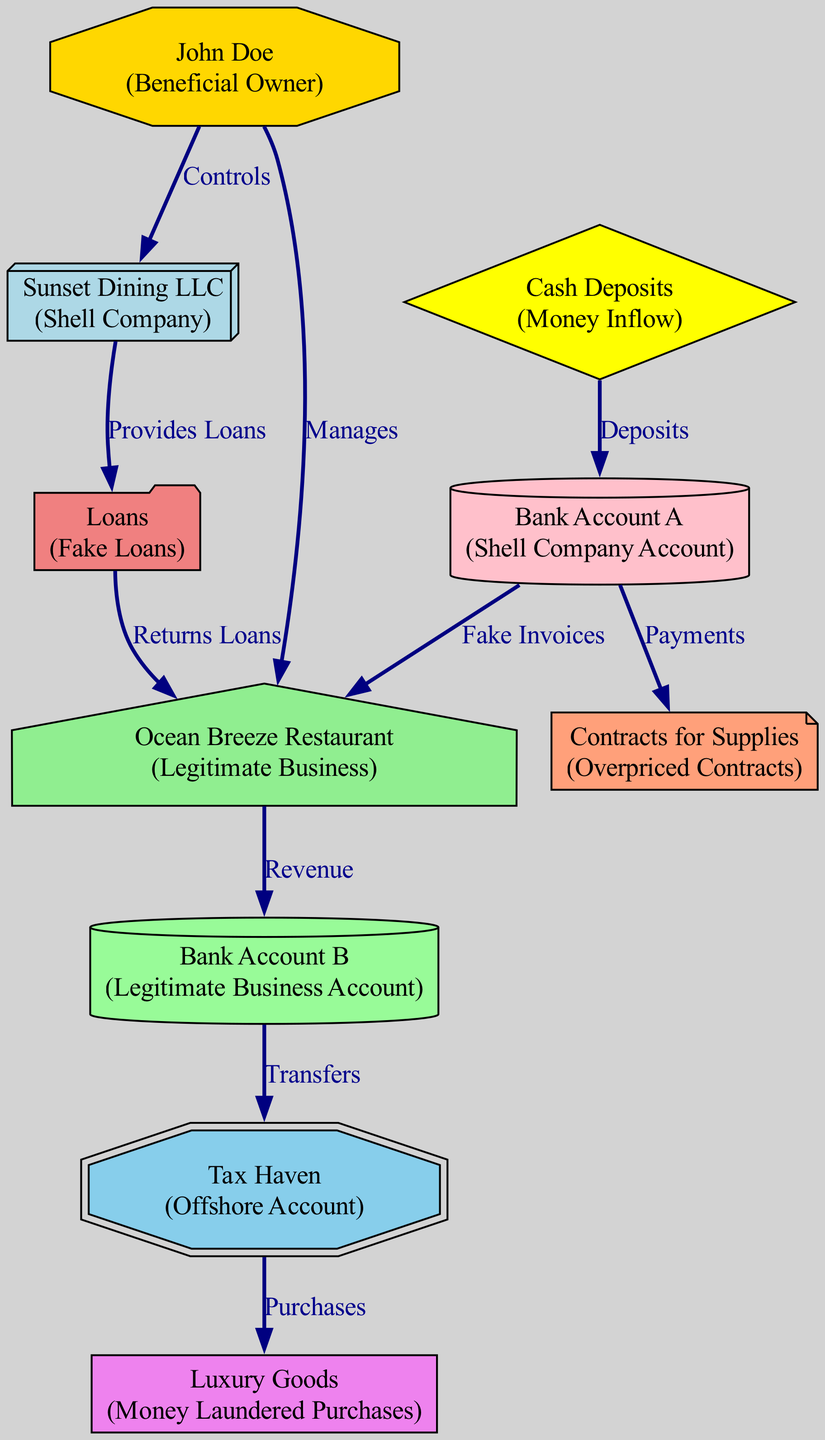What is the total number of nodes in the diagram? The diagram lists 10 distinct entities, including both companies and accounts. Each unique label represents a node in the structure.
Answer: 10 Who is the beneficial owner of Sunset Dining LLC? John Doe is identified in the diagram as the individual who controls the shell company, Sunset Dining LLC, indicating his role as beneficial owner.
Answer: John Doe What type of business is Ocean Breeze Restaurant? The diagram classifies Ocean Breeze Restaurant as a legitimate business, which is indicated by its label and description.
Answer: Legitimate Business Which node receives deposits from cash inflow? The cash deposits, represented in the diagram, flow into Bank Account A, which is the account associated with the shell company.
Answer: Bank Account A What financial action is taken by Sunset Dining LLC regarding loans? Sunset Dining LLC provides fake loans to the legitimate business, Ocean Breeze Restaurant, as shown in the edge describing their relationship.
Answer: Provides Loans What type of transactions occur between Bank Account B and the Tax Haven? Bank Account B performs transfers to the Tax Haven, as indicated in the diagram's edge labeling the flow and connection between these two elements.
Answer: Transfers How does money laundered through purchases return to John Doe? The flow depicts that luxury goods purchased through the offshore account are ultimately linked back to John Doe via the sequence of financial transactions leading to the shell company.
Answer: Luxury Goods Which entity manages Ocean Breeze Restaurant? John Doe, identified as the beneficial owner, manages Ocean Breeze Restaurant according to the diagram, representing his control over this legitimate business.
Answer: Manages What type of contracts are associated with Bank Account A? The diagram notes that Bank Account A handles overpriced contracts for supplies, indicating financial irregularities linked to this account.
Answer: Overpriced Contracts What is the purpose of the offshore account in this diagram? The offshore account, labeled as a tax haven, serves to facilitate the laundering of money through the purchase of luxury goods, based on the flow of data in the diagram.
Answer: Offshore Account 